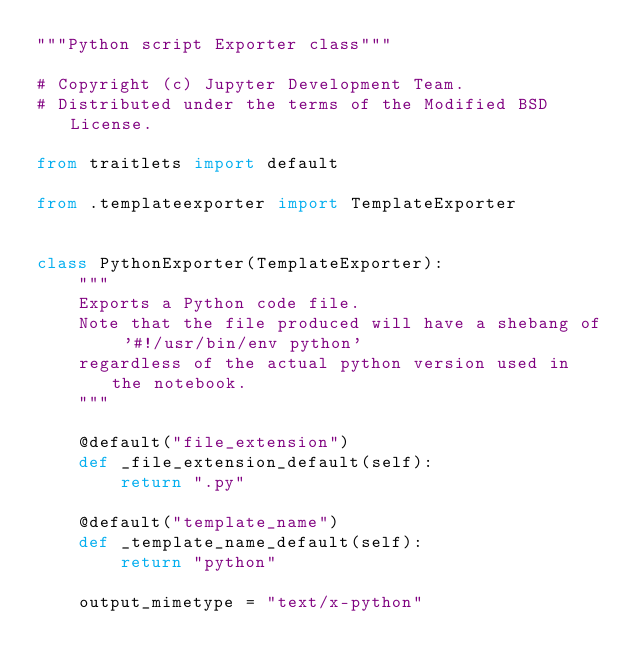Convert code to text. <code><loc_0><loc_0><loc_500><loc_500><_Python_>"""Python script Exporter class"""

# Copyright (c) Jupyter Development Team.
# Distributed under the terms of the Modified BSD License.

from traitlets import default

from .templateexporter import TemplateExporter


class PythonExporter(TemplateExporter):
    """
    Exports a Python code file.
    Note that the file produced will have a shebang of '#!/usr/bin/env python'
    regardless of the actual python version used in the notebook.
    """

    @default("file_extension")
    def _file_extension_default(self):
        return ".py"

    @default("template_name")
    def _template_name_default(self):
        return "python"

    output_mimetype = "text/x-python"
</code> 